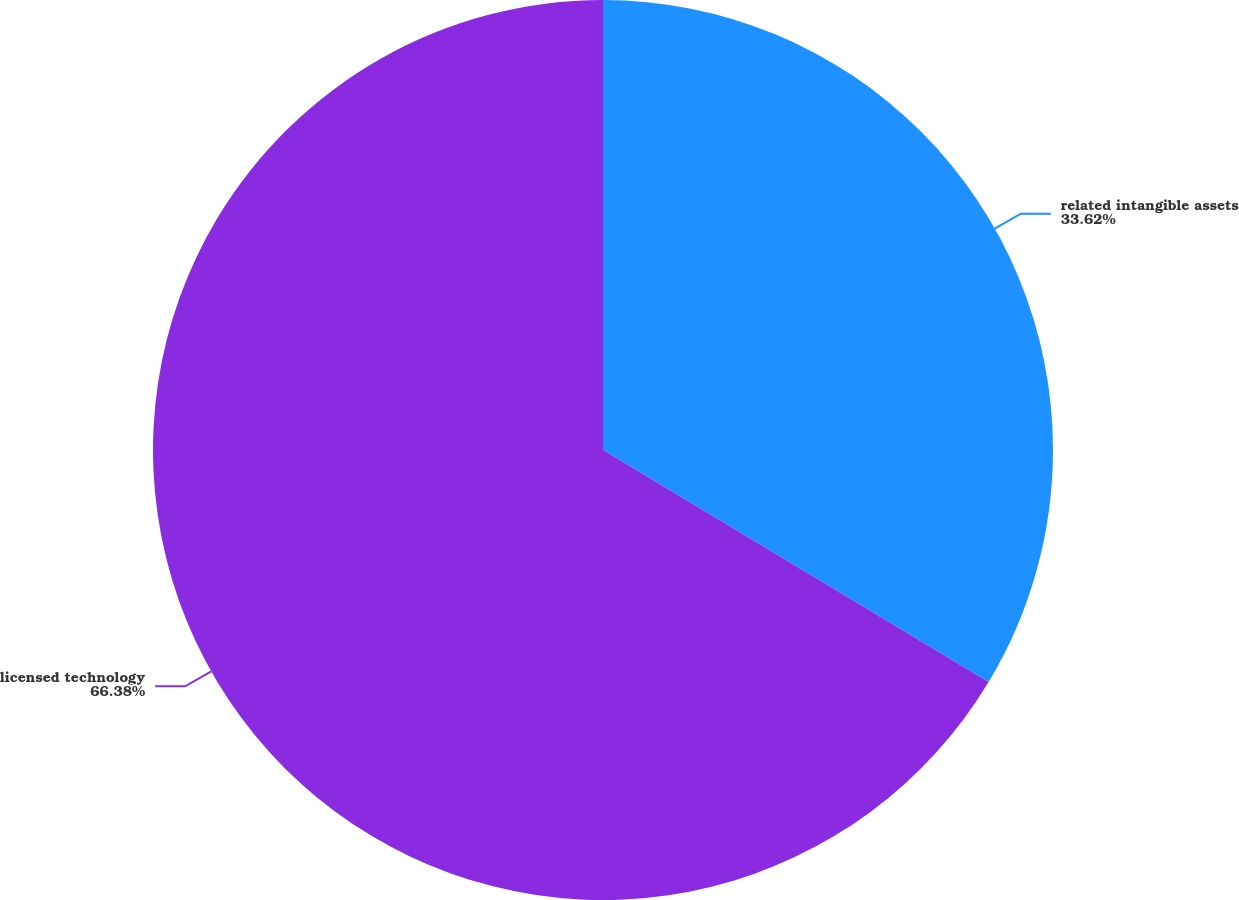Convert chart to OTSL. <chart><loc_0><loc_0><loc_500><loc_500><pie_chart><fcel>related intangible assets<fcel>licensed technology<nl><fcel>33.62%<fcel>66.38%<nl></chart> 